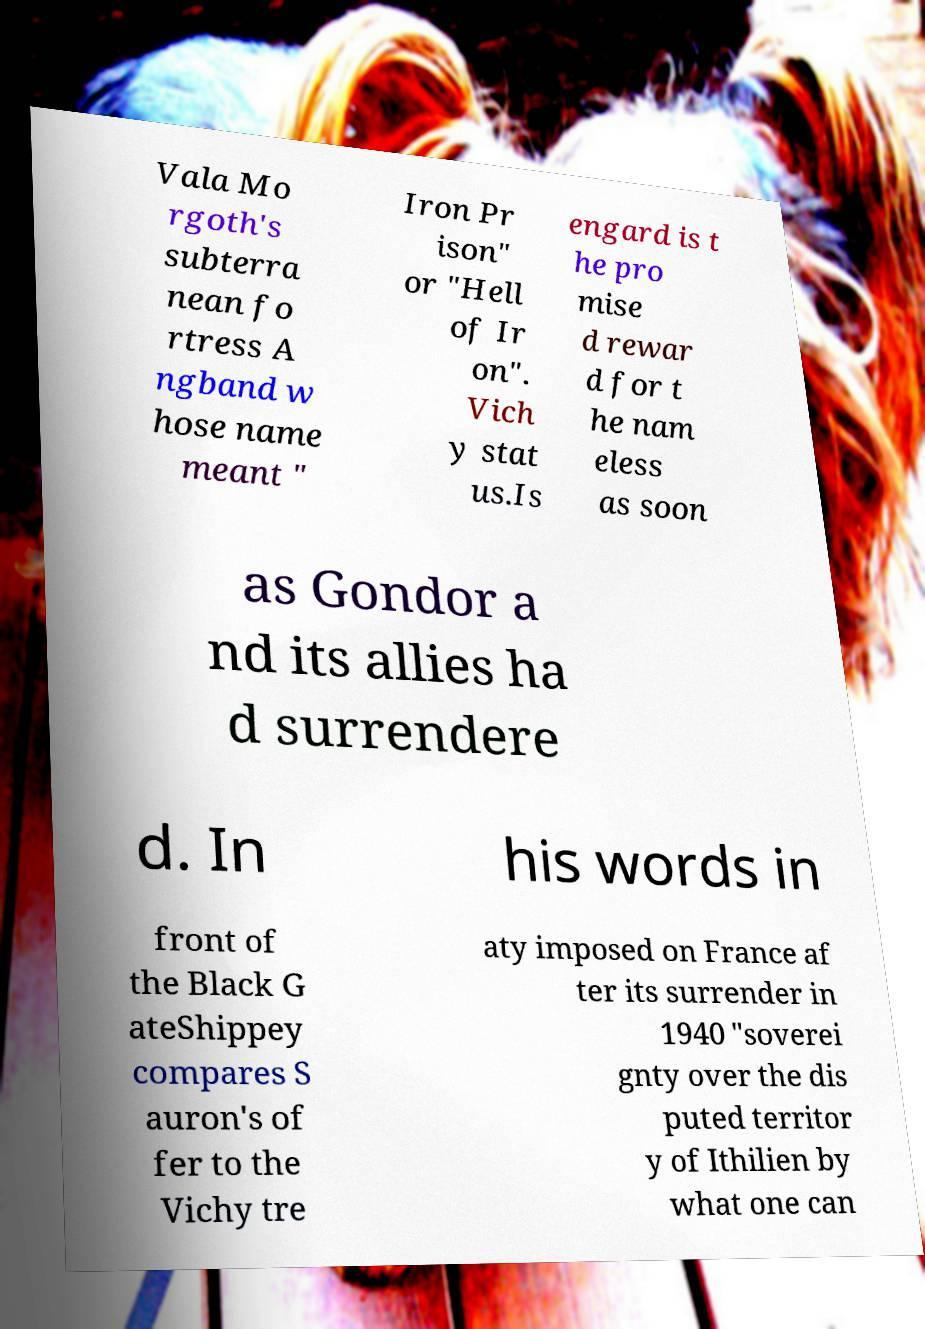I need the written content from this picture converted into text. Can you do that? Vala Mo rgoth's subterra nean fo rtress A ngband w hose name meant " Iron Pr ison" or "Hell of Ir on". Vich y stat us.Is engard is t he pro mise d rewar d for t he nam eless as soon as Gondor a nd its allies ha d surrendere d. In his words in front of the Black G ateShippey compares S auron's of fer to the Vichy tre aty imposed on France af ter its surrender in 1940 "soverei gnty over the dis puted territor y of Ithilien by what one can 